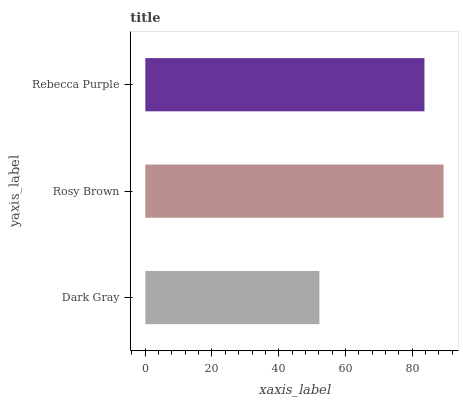Is Dark Gray the minimum?
Answer yes or no. Yes. Is Rosy Brown the maximum?
Answer yes or no. Yes. Is Rebecca Purple the minimum?
Answer yes or no. No. Is Rebecca Purple the maximum?
Answer yes or no. No. Is Rosy Brown greater than Rebecca Purple?
Answer yes or no. Yes. Is Rebecca Purple less than Rosy Brown?
Answer yes or no. Yes. Is Rebecca Purple greater than Rosy Brown?
Answer yes or no. No. Is Rosy Brown less than Rebecca Purple?
Answer yes or no. No. Is Rebecca Purple the high median?
Answer yes or no. Yes. Is Rebecca Purple the low median?
Answer yes or no. Yes. Is Dark Gray the high median?
Answer yes or no. No. Is Rosy Brown the low median?
Answer yes or no. No. 